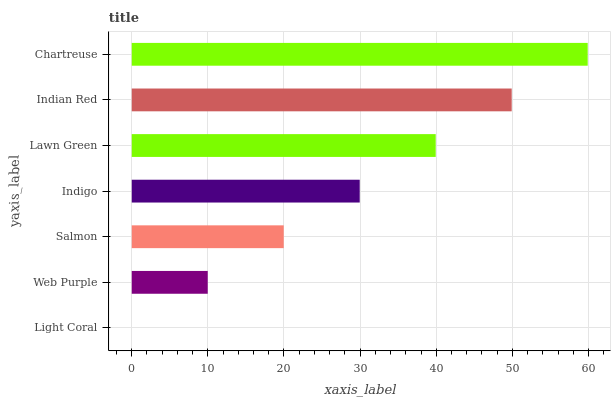Is Light Coral the minimum?
Answer yes or no. Yes. Is Chartreuse the maximum?
Answer yes or no. Yes. Is Web Purple the minimum?
Answer yes or no. No. Is Web Purple the maximum?
Answer yes or no. No. Is Web Purple greater than Light Coral?
Answer yes or no. Yes. Is Light Coral less than Web Purple?
Answer yes or no. Yes. Is Light Coral greater than Web Purple?
Answer yes or no. No. Is Web Purple less than Light Coral?
Answer yes or no. No. Is Indigo the high median?
Answer yes or no. Yes. Is Indigo the low median?
Answer yes or no. Yes. Is Light Coral the high median?
Answer yes or no. No. Is Web Purple the low median?
Answer yes or no. No. 